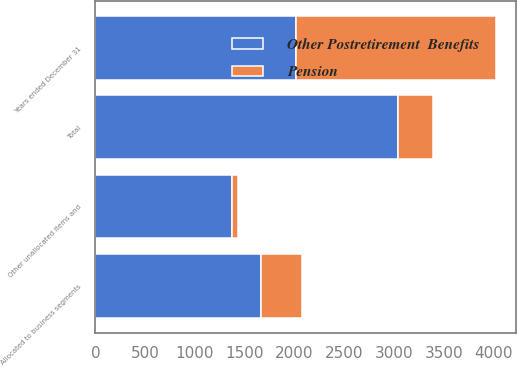<chart> <loc_0><loc_0><loc_500><loc_500><stacked_bar_chart><ecel><fcel>Years ended December 31<fcel>Allocated to business segments<fcel>Other unallocated items and<fcel>Total<nl><fcel>Other Postretirement  Benefits<fcel>2013<fcel>1662<fcel>1374<fcel>3036<nl><fcel>Pension<fcel>2013<fcel>413<fcel>60<fcel>353<nl></chart> 